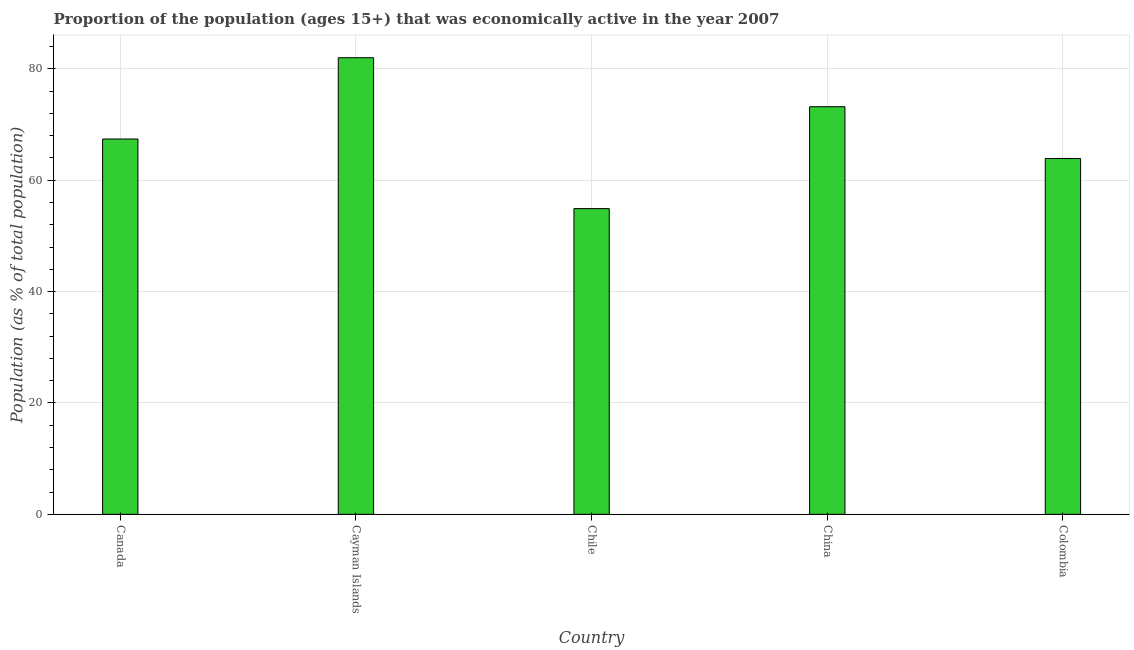Does the graph contain grids?
Provide a succinct answer. Yes. What is the title of the graph?
Offer a terse response. Proportion of the population (ages 15+) that was economically active in the year 2007. What is the label or title of the X-axis?
Provide a succinct answer. Country. What is the label or title of the Y-axis?
Your answer should be very brief. Population (as % of total population). What is the percentage of economically active population in China?
Keep it short and to the point. 73.2. Across all countries, what is the maximum percentage of economically active population?
Your response must be concise. 82. Across all countries, what is the minimum percentage of economically active population?
Offer a very short reply. 54.9. In which country was the percentage of economically active population maximum?
Give a very brief answer. Cayman Islands. In which country was the percentage of economically active population minimum?
Your answer should be very brief. Chile. What is the sum of the percentage of economically active population?
Provide a short and direct response. 341.4. What is the difference between the percentage of economically active population in Cayman Islands and Colombia?
Your response must be concise. 18.1. What is the average percentage of economically active population per country?
Ensure brevity in your answer.  68.28. What is the median percentage of economically active population?
Keep it short and to the point. 67.4. In how many countries, is the percentage of economically active population greater than 40 %?
Offer a very short reply. 5. What is the ratio of the percentage of economically active population in Canada to that in Colombia?
Your answer should be very brief. 1.05. What is the difference between the highest and the second highest percentage of economically active population?
Provide a short and direct response. 8.8. Is the sum of the percentage of economically active population in Canada and China greater than the maximum percentage of economically active population across all countries?
Offer a very short reply. Yes. What is the difference between the highest and the lowest percentage of economically active population?
Provide a short and direct response. 27.1. How many bars are there?
Offer a very short reply. 5. Are all the bars in the graph horizontal?
Your response must be concise. No. What is the Population (as % of total population) in Canada?
Provide a succinct answer. 67.4. What is the Population (as % of total population) in Chile?
Make the answer very short. 54.9. What is the Population (as % of total population) of China?
Your answer should be very brief. 73.2. What is the Population (as % of total population) of Colombia?
Make the answer very short. 63.9. What is the difference between the Population (as % of total population) in Canada and Cayman Islands?
Offer a terse response. -14.6. What is the difference between the Population (as % of total population) in Canada and Chile?
Keep it short and to the point. 12.5. What is the difference between the Population (as % of total population) in Canada and China?
Your response must be concise. -5.8. What is the difference between the Population (as % of total population) in Cayman Islands and Chile?
Your response must be concise. 27.1. What is the difference between the Population (as % of total population) in Chile and China?
Give a very brief answer. -18.3. What is the difference between the Population (as % of total population) in Chile and Colombia?
Make the answer very short. -9. What is the difference between the Population (as % of total population) in China and Colombia?
Offer a very short reply. 9.3. What is the ratio of the Population (as % of total population) in Canada to that in Cayman Islands?
Provide a succinct answer. 0.82. What is the ratio of the Population (as % of total population) in Canada to that in Chile?
Your answer should be compact. 1.23. What is the ratio of the Population (as % of total population) in Canada to that in China?
Keep it short and to the point. 0.92. What is the ratio of the Population (as % of total population) in Canada to that in Colombia?
Make the answer very short. 1.05. What is the ratio of the Population (as % of total population) in Cayman Islands to that in Chile?
Keep it short and to the point. 1.49. What is the ratio of the Population (as % of total population) in Cayman Islands to that in China?
Offer a terse response. 1.12. What is the ratio of the Population (as % of total population) in Cayman Islands to that in Colombia?
Offer a very short reply. 1.28. What is the ratio of the Population (as % of total population) in Chile to that in China?
Give a very brief answer. 0.75. What is the ratio of the Population (as % of total population) in Chile to that in Colombia?
Provide a succinct answer. 0.86. What is the ratio of the Population (as % of total population) in China to that in Colombia?
Your answer should be very brief. 1.15. 